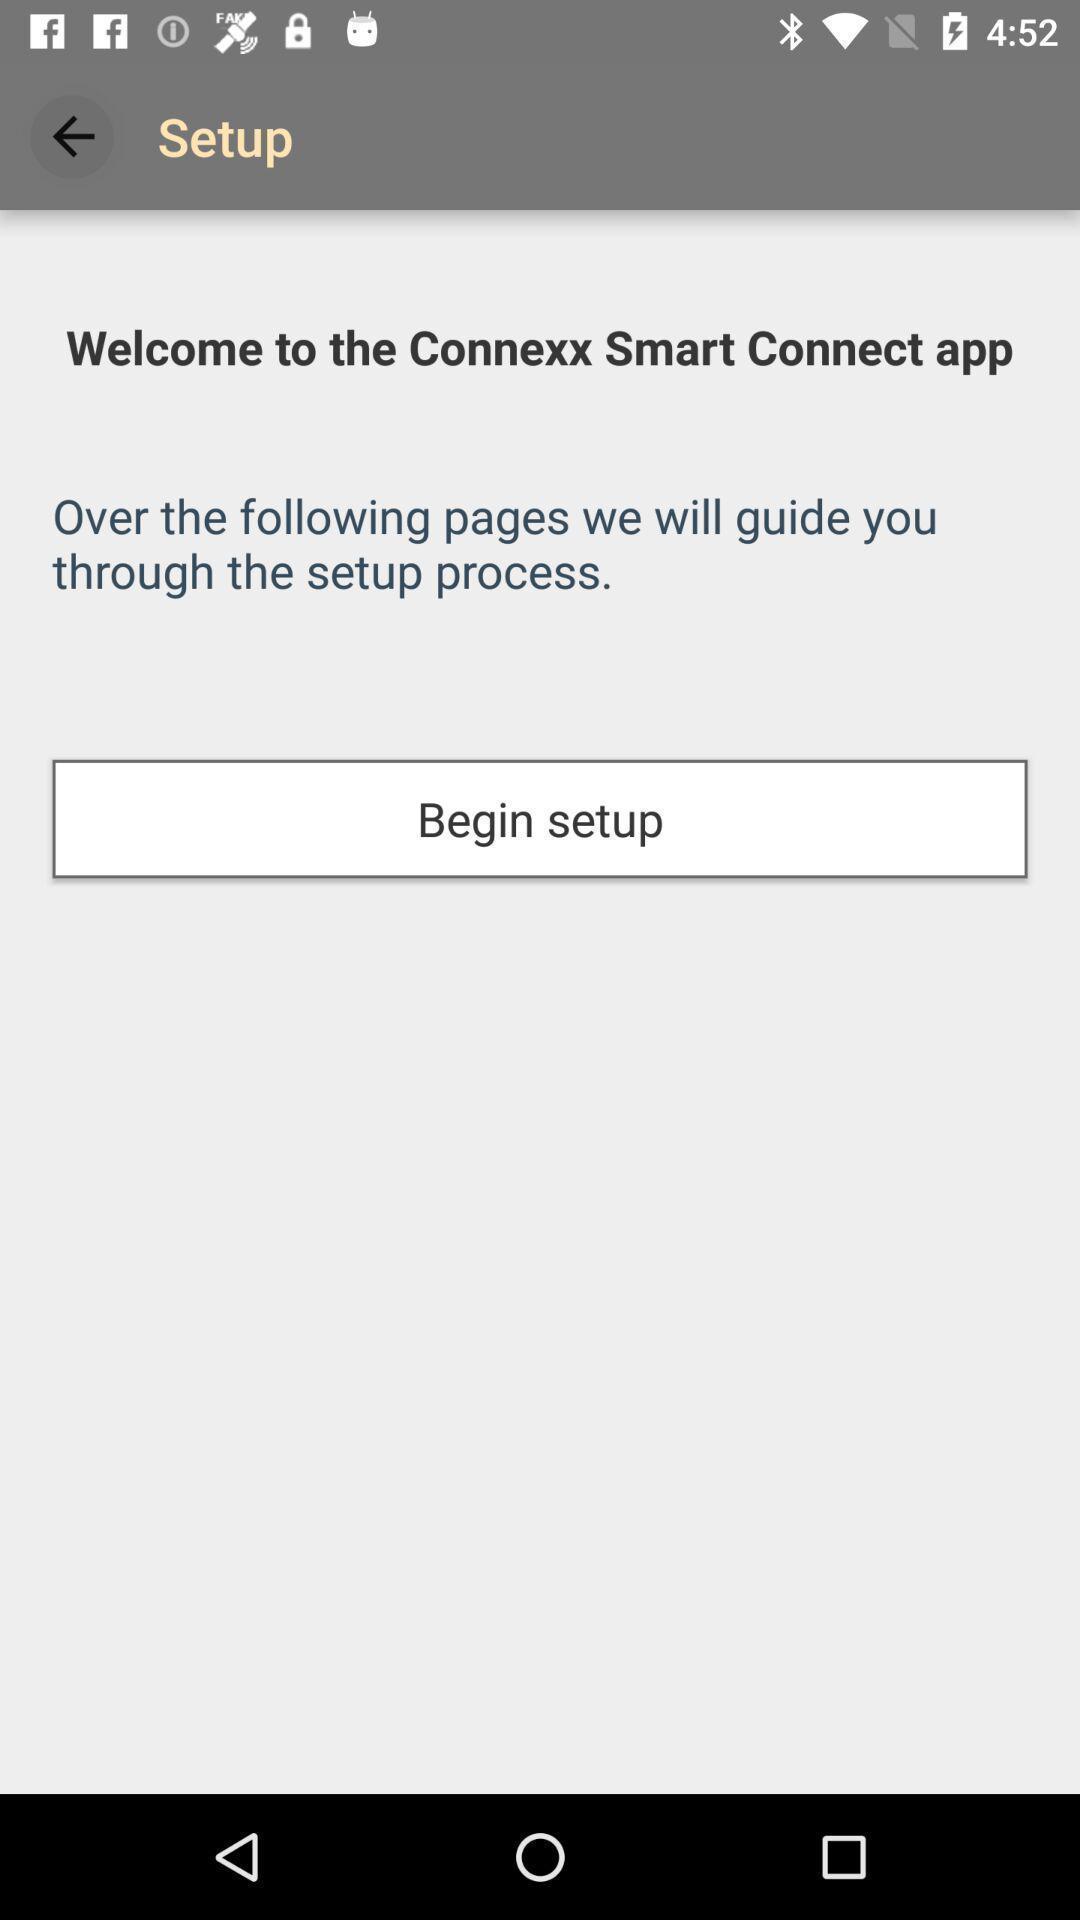Give me a narrative description of this picture. Welcome page. 